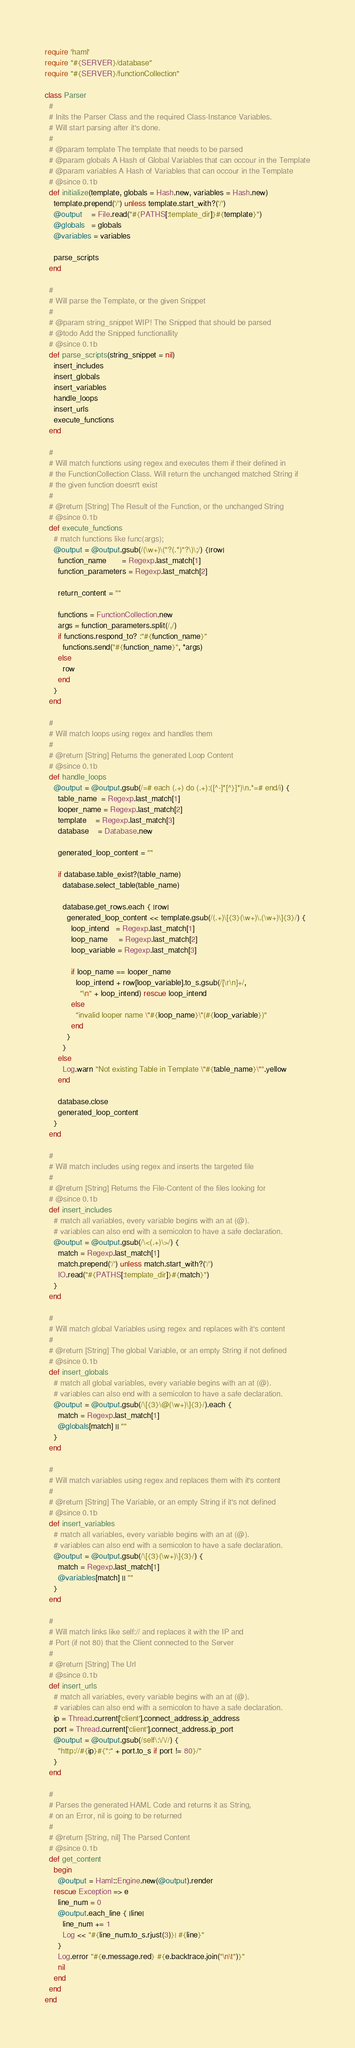Convert code to text. <code><loc_0><loc_0><loc_500><loc_500><_Ruby_>require 'haml'
require "#{SERVER}/database"
require "#{SERVER}/functionCollection"

class Parser
  #
  # Inits the Parser Class and the required Class-Instance Variables.
  # Will start parsing after it's done.
  #
  # @param template The template that needs to be parsed
  # @param globals A Hash of Global Variables that can occour in the Template
  # @param variables A Hash of Variables that can occour in the Template
  # @since 0.1b
  def initialize(template, globals = Hash.new, variables = Hash.new)
    template.prepend('/') unless template.start_with?('/')
    @output    = File.read("#{PATHS[:template_dir]}#{template}")
    @globals   = globals
    @variables = variables

    parse_scripts
  end

  #
  # Will parse the Template, or the given Snippet
  #
  # @param string_snippet WIP! The Snipped that should be parsed
  # @todo Add the Snipped functionallity
  # @since 0.1b
  def parse_scripts(string_snippet = nil)
    insert_includes
    insert_globals
    insert_variables
    handle_loops
    insert_urls
    execute_functions
  end

  #
  # Will match functions using regex and executes them if their defined in
  # the FunctionCollection Class. Will return the unchanged matched String if
  # the given function doesn't exist
  #
  # @return [String] The Result of the Function, or the unchanged String
  # @since 0.1b
  def execute_functions
    # match functions like func(args);
    @output = @output.gsub(/(\w+)\("?(.*)"?\)\;/) {|row|
      function_name       = Regexp.last_match[1]
      function_parameters = Regexp.last_match[2]

      return_content = ""

      functions = FunctionCollection.new
      args = function_parameters.split(/,/)
      if functions.respond_to? :"#{function_name}"
        functions.send("#{function_name}", *args)
      else
        row
      end
    }
  end

  #
  # Will match loops using regex and handles them
  #
  # @return [String] Returns the generated Loop Content
  # @since 0.1b
  def handle_loops
    @output = @output.gsub(/=# each (.+) do (.+):([^-]*[^}]*)\n.*=# end/i) {
      table_name  = Regexp.last_match[1]
      looper_name = Regexp.last_match[2]
      template    = Regexp.last_match[3]
      database    = Database.new

      generated_loop_content = ""

      if database.table_exist?(table_name)
        database.select_table(table_name)

        database.get_rows.each { |row|
          generated_loop_content << template.gsub(/(.+)\[{3}(\w+)\.(\w+)\]{3}/) {
            loop_intend   = Regexp.last_match[1]
            loop_name     = Regexp.last_match[2]
            loop_variable = Regexp.last_match[3]

            if loop_name == looper_name
              loop_intend + row[loop_variable].to_s.gsub(/[\r\n]+/,
                "\n" + loop_intend) rescue loop_intend
            else
              "invalid looper name \"#{loop_name}\"(#{loop_variable})"
            end
          }
        }
      else
        Log.warn "Not existing Table in Template \"#{table_name}\"".yellow
      end

      database.close
      generated_loop_content
    }
  end

  #
  # Will match includes using regex and inserts the targeted file
  #
  # @return [String] Returns the File-Content of the files looking for
  # @since 0.1b
  def insert_includes
    # match all variables, every variable begins with an at (@).
    # variables can also end with a semicolon to have a safe declaration.
    @output = @output.gsub(/\<(.+)\>/) {
      match = Regexp.last_match[1]
      match.prepend('/') unless match.start_with?('/')
      IO.read("#{PATHS[:template_dir]}#{match}")
    }
  end

  #
  # Will match global Variables using regex and replaces with it's content
  #
  # @return [String] The global Variable, or an empty String if not defined
  # @since 0.1b
  def insert_globals
    # match all global variables, every variable begins with an at (@).
    # variables can also end with a semicolon to have a safe declaration.
    @output = @output.gsub(/\[{3}\@(\w+)\]{3}/).each {
      match = Regexp.last_match[1]
      @globals[match] || ""
    }
  end

  #
  # Will match variables using regex and replaces them with it's content
  #
  # @return [String] The Variable, or an empty String if it's not defined
  # @since 0.1b
  def insert_variables
    # match all variables, every variable begins with an at (@).
    # variables can also end with a semicolon to have a safe declaration.
    @output = @output.gsub(/\[{3}(\w+)\]{3}/) {
      match = Regexp.last_match[1]
      @variables[match] || ""
    }
  end

  #
  # Will match links like self:// and replaces it with the IP and
  # Port (if not 80) that the Client connected to the Server
  #
  # @return [String] The Url
  # @since 0.1b
  def insert_urls
    # match all variables, every variable begins with an at (@).
    # variables can also end with a semicolon to have a safe declaration.
    ip = Thread.current['client'].connect_address.ip_address
    port = Thread.current['client'].connect_address.ip_port
    @output = @output.gsub(/self\:\/\//) {
      "http://#{ip}#{":" + port.to_s if port != 80}/"
    }
  end

  #
  # Parses the generated HAML Code and returns it as String,
  # on an Error, nil is going to be returned
  #
  # @return [String, nil] The Parsed Content
  # @since 0.1b
  def get_content
    begin
      @output = Haml::Engine.new(@output).render
    rescue Exception => e
      line_num = 0
      @output.each_line { |line|
        line_num += 1
        Log << "#{line_num.to_s.rjust(3)}| #{line}"
      }
      Log.error "#{e.message.red} #{e.backtrace.join("\n\t")}"
      nil
    end
  end
end
</code> 